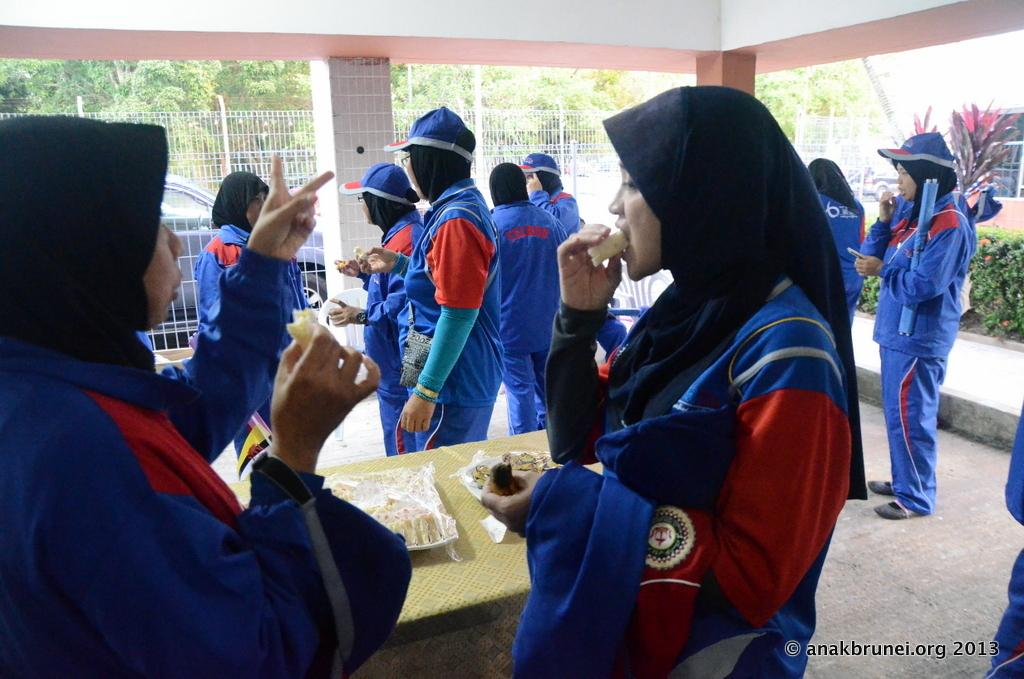Who or what can be seen in the image? There are people in the image. What can be seen in the distance behind the people? There is a car, a rail, and trees in the background of the image. What type of cable is being used by the son in the image? There is no son or cable present in the image. 